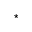<formula> <loc_0><loc_0><loc_500><loc_500>^ { ^ { * } }</formula> 